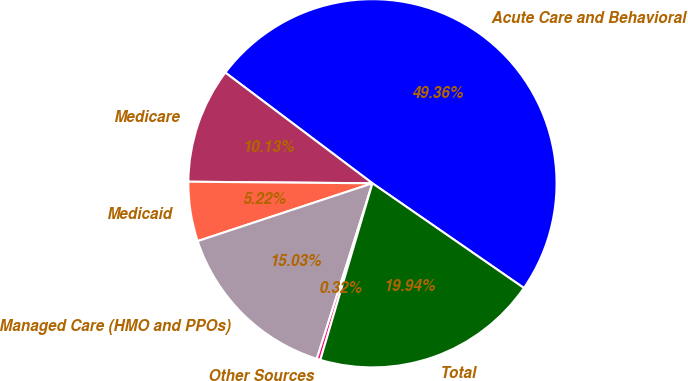Convert chart. <chart><loc_0><loc_0><loc_500><loc_500><pie_chart><fcel>Acute Care and Behavioral<fcel>Medicare<fcel>Medicaid<fcel>Managed Care (HMO and PPOs)<fcel>Other Sources<fcel>Total<nl><fcel>49.36%<fcel>10.13%<fcel>5.22%<fcel>15.03%<fcel>0.32%<fcel>19.94%<nl></chart> 